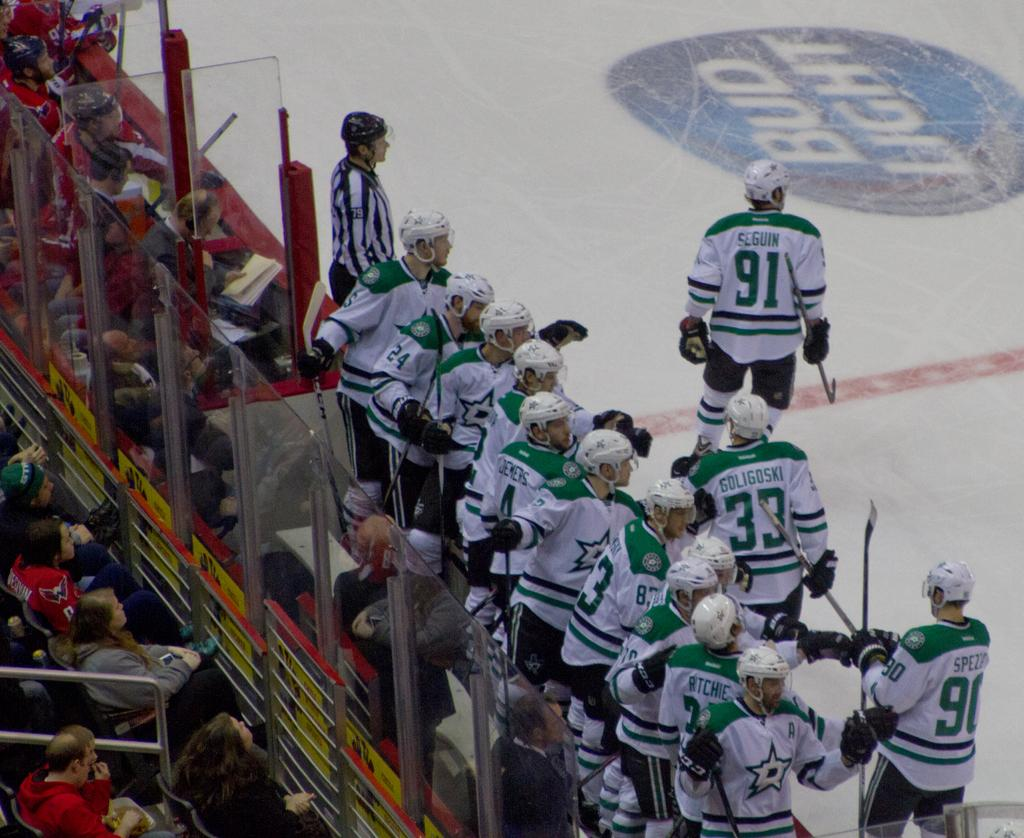<image>
Summarize the visual content of the image. Hockey players on the court with one wearing number 33 jersey. 